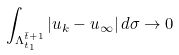Convert formula to latex. <formula><loc_0><loc_0><loc_500><loc_500>\int _ { \Lambda _ { t _ { 1 } } ^ { \bar { t } + 1 } } | u _ { k } - u _ { \infty } | \, d \sigma \rightarrow 0 \,</formula> 